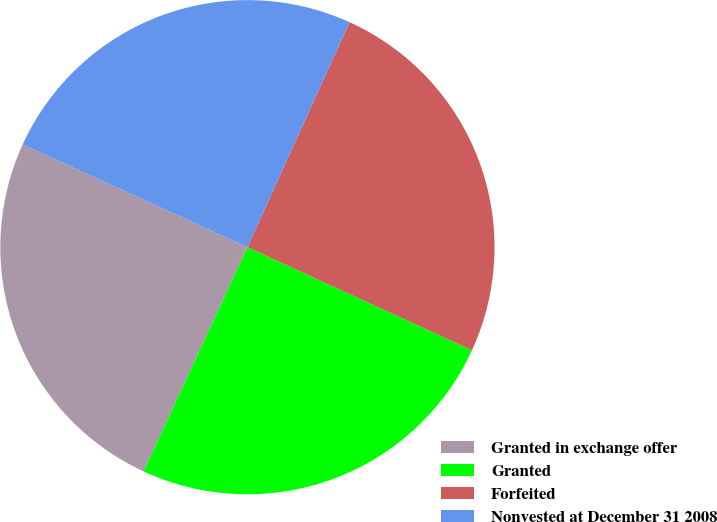Convert chart. <chart><loc_0><loc_0><loc_500><loc_500><pie_chart><fcel>Granted in exchange offer<fcel>Granted<fcel>Forfeited<fcel>Nonvested at December 31 2008<nl><fcel>24.92%<fcel>25.05%<fcel>25.07%<fcel>24.96%<nl></chart> 